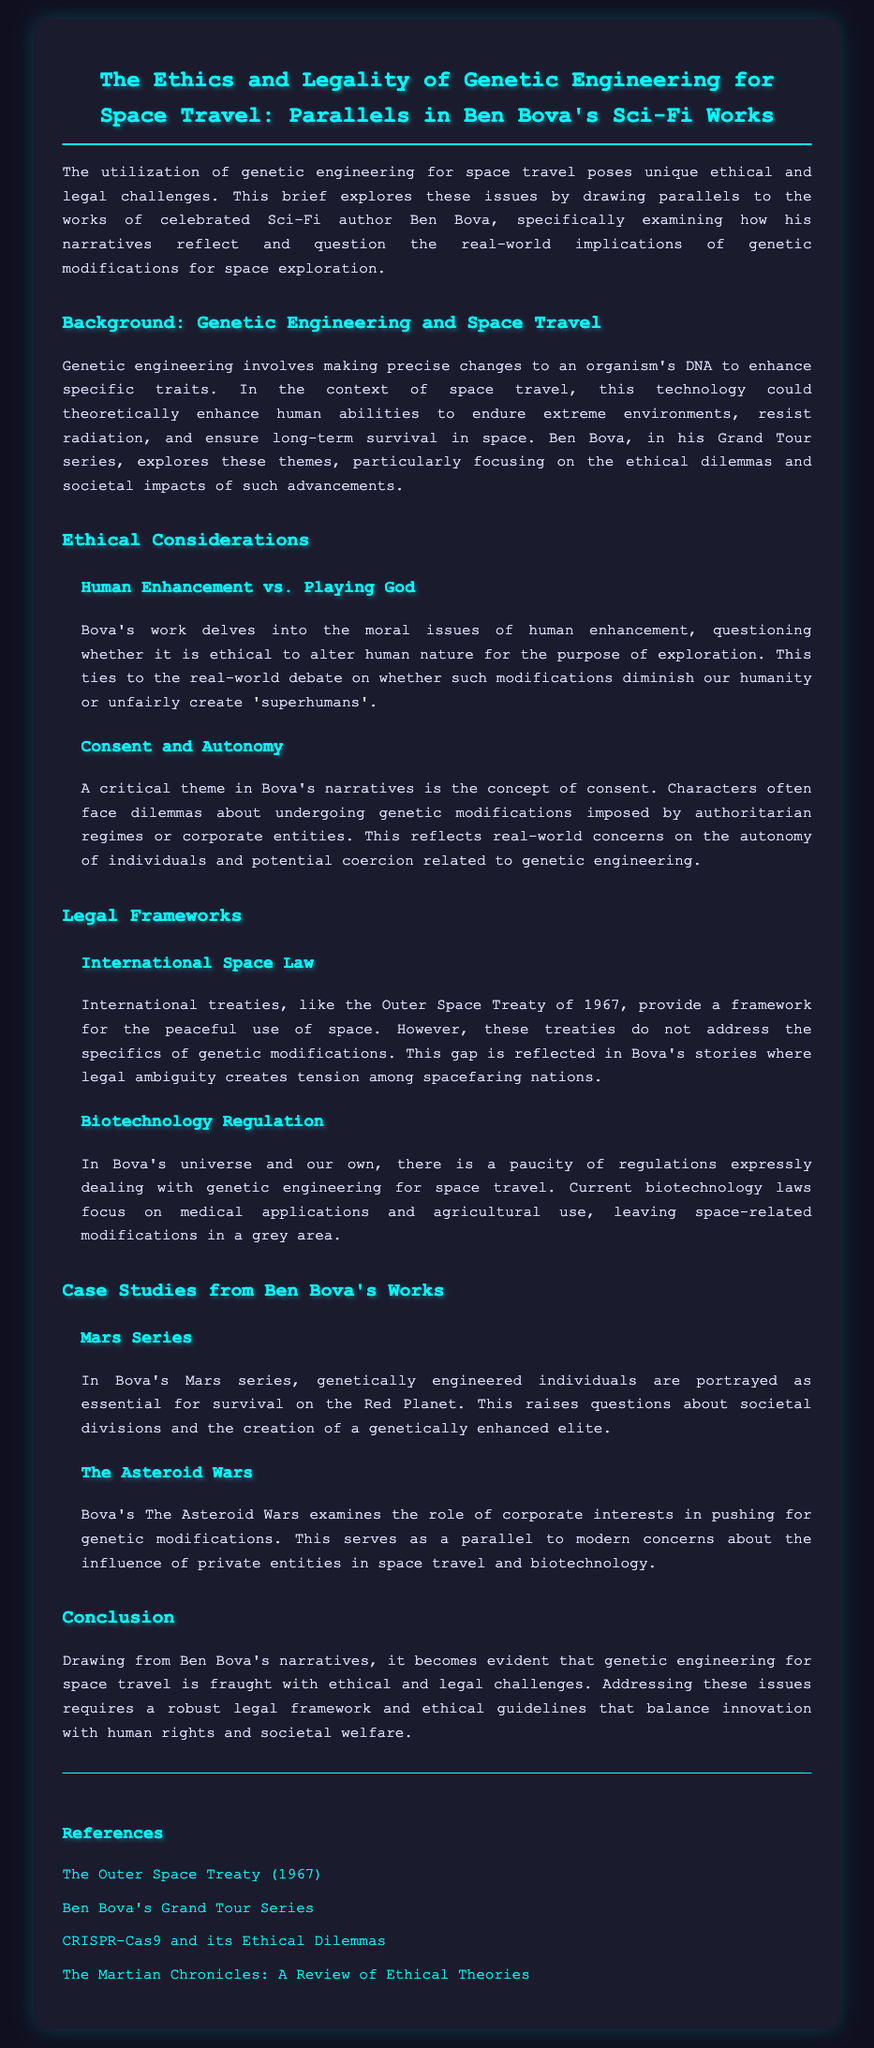What is the title of the legal brief? The title is stated prominently at the beginning of the document.
Answer: The Ethics and Legality of Genetic Engineering for Space Travel: Parallels in Ben Bova's Sci-Fi Works What year was the Outer Space Treaty established? The date is found in the section discussing International Space Law.
Answer: 1967 What is one of the critical themes in Bova's narratives? The document discusses key themes related to consent and autonomy in the context of genetic modifications.
Answer: Consent Which series by Ben Bova is mentioned as exploring genetic engineering? The series is specified in the Background section discussing his exploration of such themes.
Answer: Grand Tour What does the term "playing God" refer to in the document? This phrase is used to describe ethical dilemmas regarding human enhancement in Bova's work.
Answer: Human Enhancement What are genetic modifications leading to in Bova's Mars series? The document describes outcomes of these modifications in terms of societal impacts.
Answer: A genetically enhanced elite What legal ambiguity is reflected in Bova's stories? The discussion of legal frameworks highlights gaps in treaties regarding genetic modifications.
Answer: Legal ambiguity In which section does the document discuss biotechnology regulations? This content is covered under the section about Legal Frameworks, specifically Biotechnology Regulation.
Answer: Legal Frameworks What societal issue arises from the genetic modifications in the Mars series? The document emphasizes concerns regarding divisions in society as a result of modifications.
Answer: Societal divisions 